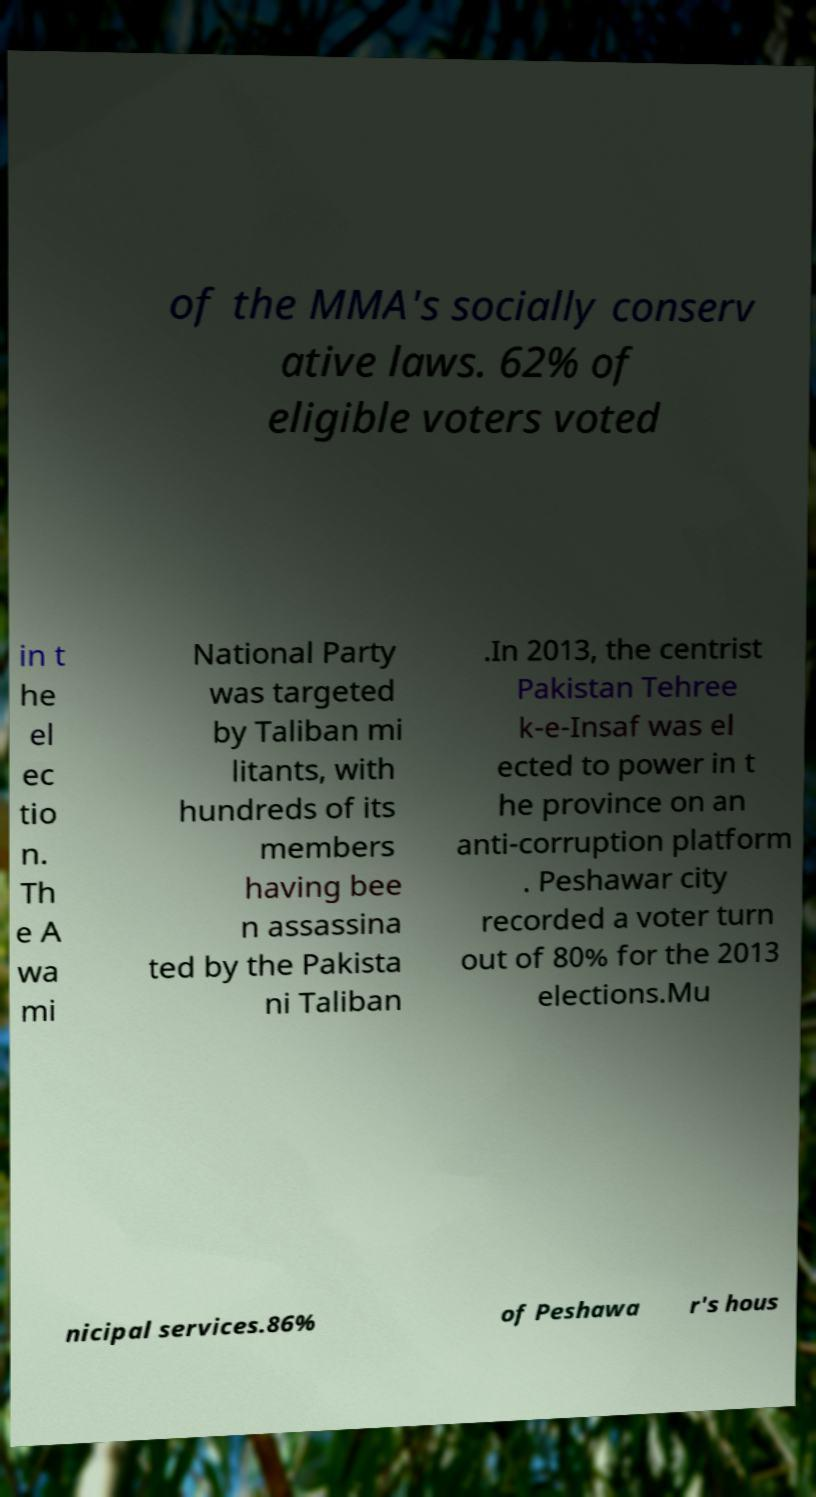What messages or text are displayed in this image? I need them in a readable, typed format. of the MMA's socially conserv ative laws. 62% of eligible voters voted in t he el ec tio n. Th e A wa mi National Party was targeted by Taliban mi litants, with hundreds of its members having bee n assassina ted by the Pakista ni Taliban .In 2013, the centrist Pakistan Tehree k-e-Insaf was el ected to power in t he province on an anti-corruption platform . Peshawar city recorded a voter turn out of 80% for the 2013 elections.Mu nicipal services.86% of Peshawa r's hous 